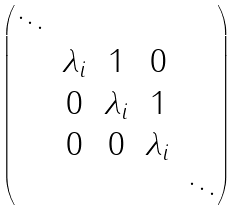<formula> <loc_0><loc_0><loc_500><loc_500>\begin{pmatrix} \ddots & & & & \\ & \lambda _ { i } & 1 & 0 & \\ & 0 & \lambda _ { i } & 1 & \\ & 0 & 0 & \lambda _ { i } & \\ & & & & \ddots \end{pmatrix}</formula> 